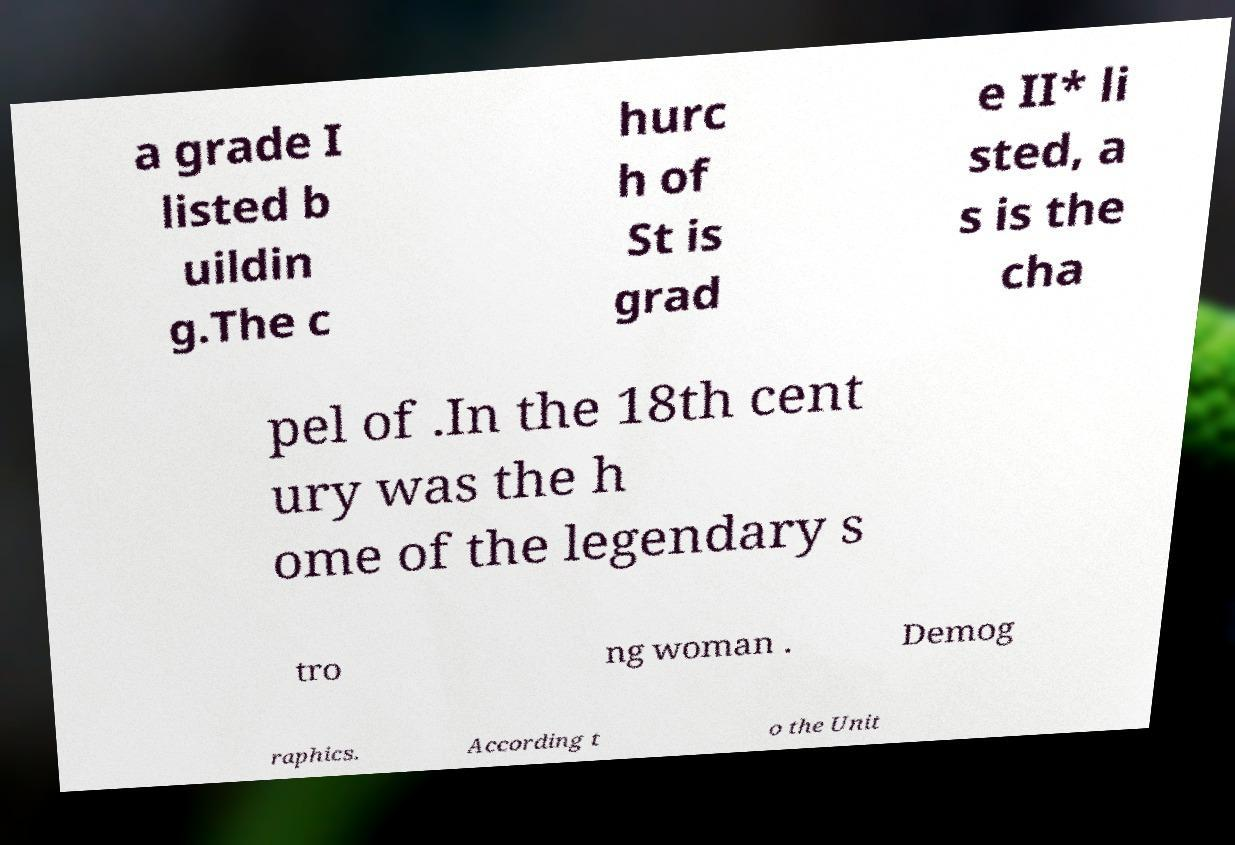Could you extract and type out the text from this image? a grade I listed b uildin g.The c hurc h of St is grad e II* li sted, a s is the cha pel of .In the 18th cent ury was the h ome of the legendary s tro ng woman . Demog raphics. According t o the Unit 